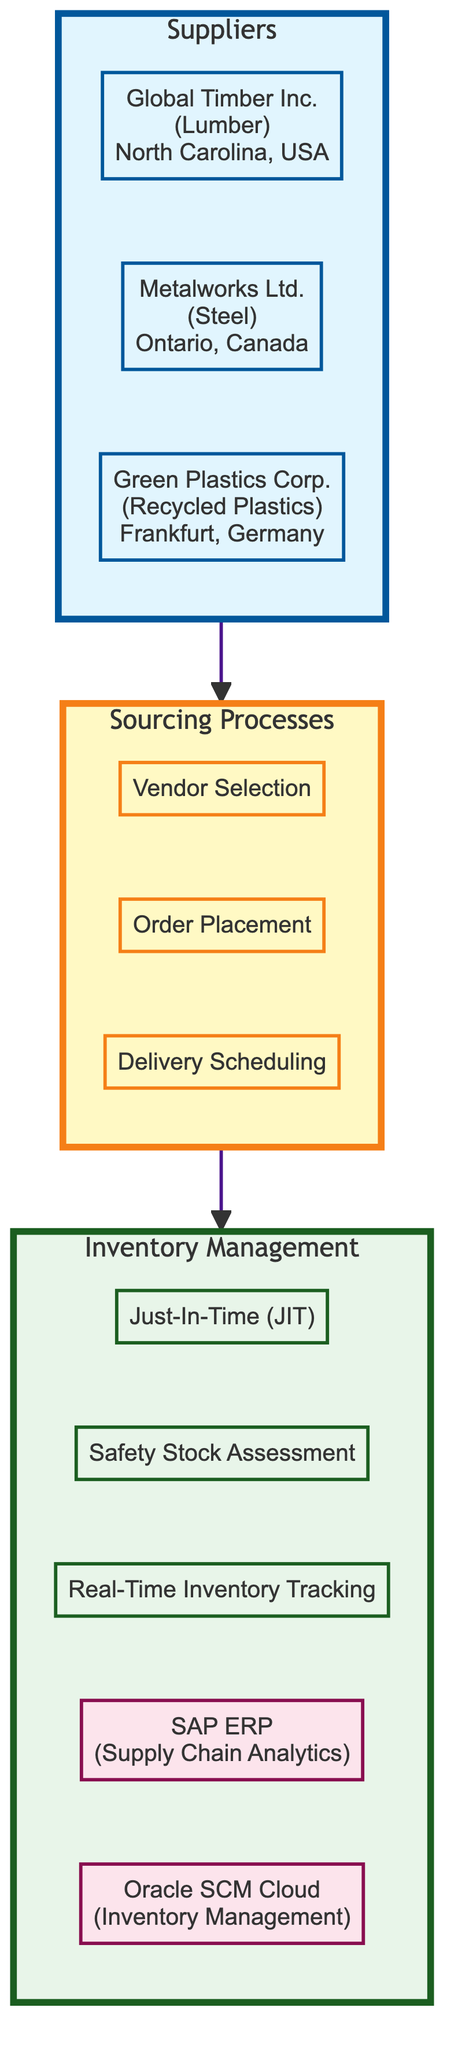What are the suppliers listed in the diagram? The diagram shows three suppliers: Global Timber Inc., Metalworks Ltd., and Green Plastics Corp.
Answer: Global Timber Inc., Metalworks Ltd., Green Plastics Corp How many sourcing processes are indicated in the diagram? The diagram indicates three sourcing processes: Vendor Selection, Order Placement, and Delivery Scheduling. By counting them, we identify that there are three.
Answer: 3 What material does Metalworks Ltd. supply? In the diagram, Metalworks Ltd. is explicitly mentioned as supplying Steel.
Answer: Steel What is one technique used in inventory management? The diagram lists several inventory management techniques. One example is Just-In-Time (JIT).
Answer: Just-In-Time (JIT) Which software is designated for supply chain analytics? According to the diagram, SAP ERP is the software specified for supply chain analytics purposes.
Answer: SAP ERP How does the 'Sourcing Processes' subgraph relate to the 'Suppliers' subgraph? The 'Sourcing Processes' subgraph is directly connected to the 'Suppliers' subgraph, indicating that sourcing processes stem from the suppliers. This flow implies that the suppliers influence the sourcing processes.
Answer: Suppliers influence sourcing processes What are the criteria for vendor selection? The diagram outlines three criteria for vendor selection: Quality Certifications, Price Competitiveness, and Lead Time.
Answer: Quality Certifications, Price Competitiveness, Lead Time In which country is Global Timber Inc. located? The diagram specifies that Global Timber Inc. is located in North Carolina, USA.
Answer: North Carolina, USA Which technique involves tracking inventory in real-time? Real-Time Inventory Tracking is the technique mentioned in the diagram for monitoring inventory continuously.
Answer: Real-Time Inventory Tracking What is the purpose of Oracle SCM Cloud according to the diagram? The diagram indicates that Oracle SCM Cloud is used specifically for Inventory Management purposes.
Answer: Inventory Management 